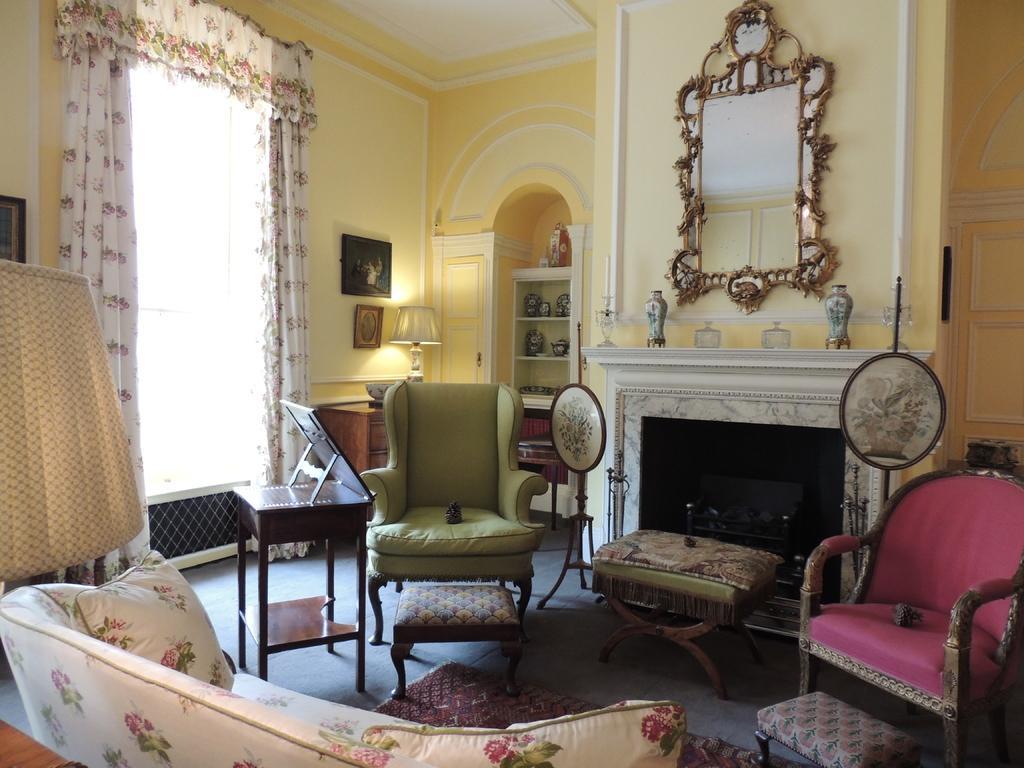Please provide a concise description of this image. In this image I see many chairs, a table, window and a curtain on it and a rack and few photo frames and few things over here. 